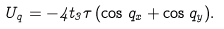Convert formula to latex. <formula><loc_0><loc_0><loc_500><loc_500>U _ { q } = - 4 t _ { 3 } \tau \, ( \cos q _ { x } + \cos q _ { y } ) .</formula> 